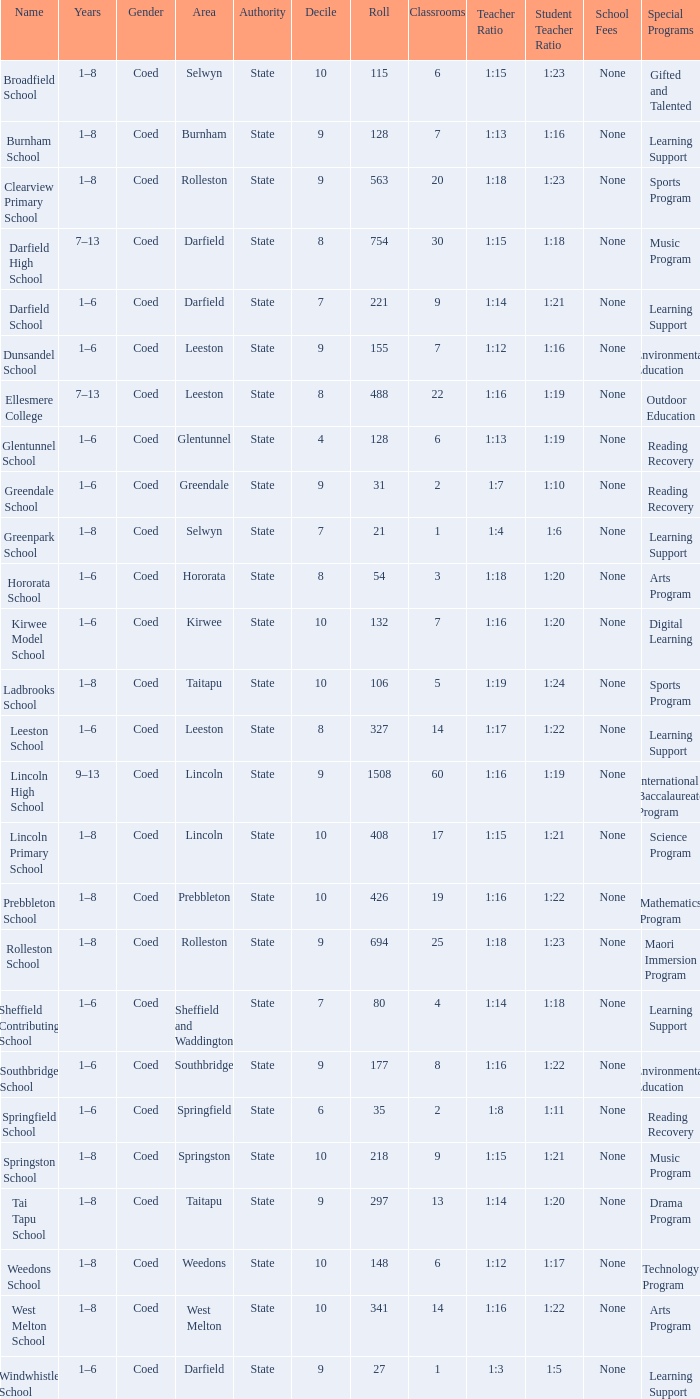Could you parse the entire table? {'header': ['Name', 'Years', 'Gender', 'Area', 'Authority', 'Decile', 'Roll', 'Classrooms', 'Teacher Ratio', 'Student Teacher Ratio', 'School Fees', 'Special Programs '], 'rows': [['Broadfield School', '1–8', 'Coed', 'Selwyn', 'State', '10', '115', '6', '1:15', '1:23', 'None', 'Gifted and Talented '], ['Burnham School', '1–8', 'Coed', 'Burnham', 'State', '9', '128', '7', '1:13', '1:16', 'None', 'Learning Support '], ['Clearview Primary School', '1–8', 'Coed', 'Rolleston', 'State', '9', '563', '20', '1:18', '1:23', 'None', 'Sports Program '], ['Darfield High School', '7–13', 'Coed', 'Darfield', 'State', '8', '754', '30', '1:15', '1:18', 'None', 'Music Program '], ['Darfield School', '1–6', 'Coed', 'Darfield', 'State', '7', '221', '9', '1:14', '1:21', 'None', 'Learning Support '], ['Dunsandel School', '1–6', 'Coed', 'Leeston', 'State', '9', '155', '7', '1:12', '1:16', 'None', 'Environmental Education '], ['Ellesmere College', '7–13', 'Coed', 'Leeston', 'State', '8', '488', '22', '1:16', '1:19', 'None', 'Outdoor Education '], ['Glentunnel School', '1–6', 'Coed', 'Glentunnel', 'State', '4', '128', '6', '1:13', '1:19', 'None', 'Reading Recovery '], ['Greendale School', '1–6', 'Coed', 'Greendale', 'State', '9', '31', '2', '1:7', '1:10', 'None', 'Reading Recovery '], ['Greenpark School', '1–8', 'Coed', 'Selwyn', 'State', '7', '21', '1', '1:4', '1:6', 'None', 'Learning Support '], ['Hororata School', '1–6', 'Coed', 'Hororata', 'State', '8', '54', '3', '1:18', '1:20', 'None', 'Arts Program '], ['Kirwee Model School', '1–6', 'Coed', 'Kirwee', 'State', '10', '132', '7', '1:16', '1:20', 'None', 'Digital Learning '], ['Ladbrooks School', '1–8', 'Coed', 'Taitapu', 'State', '10', '106', '5', '1:19', '1:24', 'None', 'Sports Program '], ['Leeston School', '1–6', 'Coed', 'Leeston', 'State', '8', '327', '14', '1:17', '1:22', 'None', 'Learning Support '], ['Lincoln High School', '9–13', 'Coed', 'Lincoln', 'State', '9', '1508', '60', '1:16', '1:19', 'None', 'International Baccalaureate Program '], ['Lincoln Primary School', '1–8', 'Coed', 'Lincoln', 'State', '10', '408', '17', '1:15', '1:21', 'None', 'Science Program '], ['Prebbleton School', '1–8', 'Coed', 'Prebbleton', 'State', '10', '426', '19', '1:16', '1:22', 'None', 'Mathematics Program '], ['Rolleston School', '1–8', 'Coed', 'Rolleston', 'State', '9', '694', '25', '1:18', '1:23', 'None', 'Maori Immersion Program '], ['Sheffield Contributing School', '1–6', 'Coed', 'Sheffield and Waddington', 'State', '7', '80', '4', '1:14', '1:18', 'None', 'Learning Support '], ['Southbridge School', '1–6', 'Coed', 'Southbridge', 'State', '9', '177', '8', '1:16', '1:22', 'None', 'Environmental Education '], ['Springfield School', '1–6', 'Coed', 'Springfield', 'State', '6', '35', '2', '1:8', '1:11', 'None', 'Reading Recovery '], ['Springston School', '1–8', 'Coed', 'Springston', 'State', '10', '218', '9', '1:15', '1:21', 'None', 'Music Program '], ['Tai Tapu School', '1–8', 'Coed', 'Taitapu', 'State', '9', '297', '13', '1:14', '1:20', 'None', 'Drama Program '], ['Weedons School', '1–8', 'Coed', 'Weedons', 'State', '10', '148', '6', '1:12', '1:17', 'None', 'Technology Program '], ['West Melton School', '1–8', 'Coed', 'West Melton', 'State', '10', '341', '14', '1:16', '1:22', 'None', 'Arts Program '], ['Windwhistle School', '1–6', 'Coed', 'Darfield', 'State', '9', '27', '1', '1:3', '1:5', 'None', 'Learning Support']]} How many deciles have Years of 9–13? 1.0. 